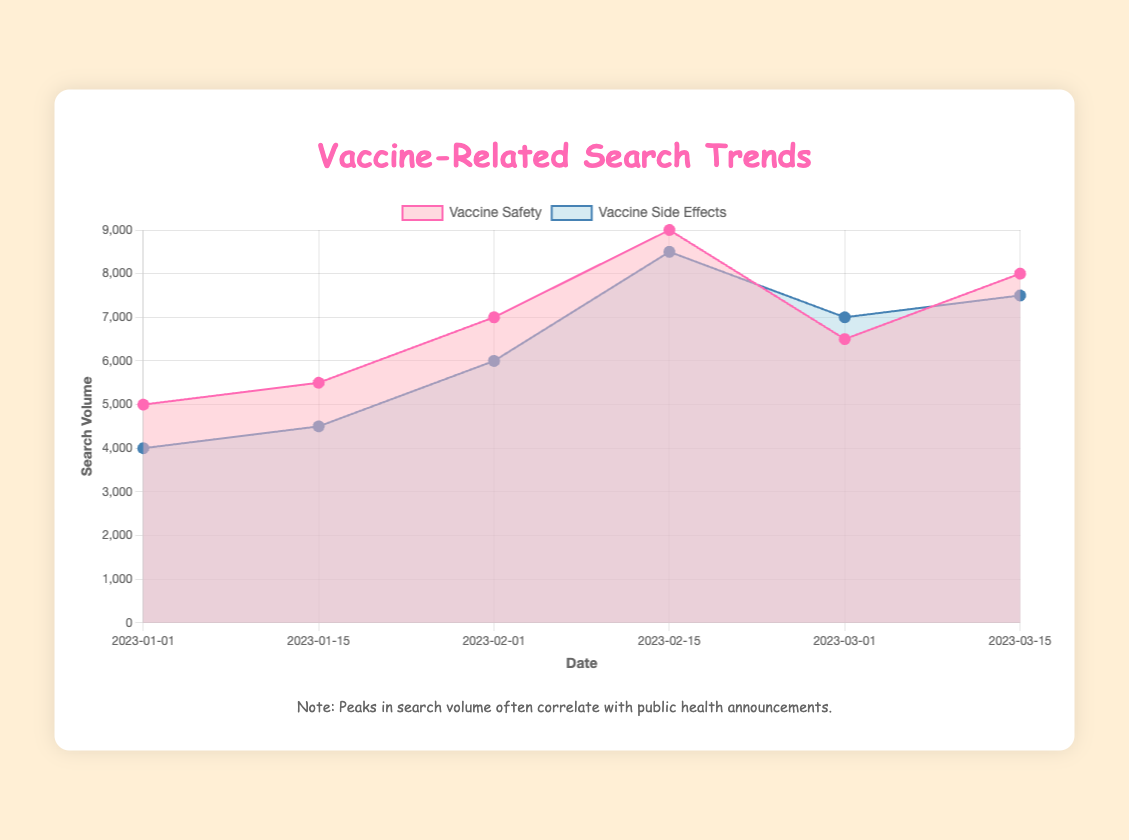What is the title of the chart? The chart's title is displayed prominently at the top of the chart's container. It provides a summary of what the chart is about.
Answer: Vaccine-Related Search Trends What are the two search terms being analyzed in the chart? The chart includes two datasets differentiated by color, and each dataset is labeled in the legend.
Answer: Vaccine Safety, Vaccine Side Effects Which search term experienced a higher search volume on February 15, 2023? By looking at the data points on February 15, 2023, it is clear which dataset has a higher search volume.
Answer: Vaccine Side Effects What visual indicators are used to represent the search volume for "vaccine safety" and "vaccine side effects"? Different colors and styles (pink for vaccine safety and blue for vaccine side effects) are used to differentiate the datasets.
Answer: Pink and Blue Areas Does the search volume for both terms increase or decrease between January 15 and February 1, 2023? By comparing the search volumes for both terms on these dates, we can observe the trends.
Answer: Increase for both What was the search volume for "vaccine safety" on March 1, 2023? Looking at the data point for "vaccine safety" on March 1, 2023, gives the answer.
Answer: 6500 How does the search volume for "vaccine side effects" on February 1, 2023, compare to the search volume for "vaccine safety" on that same date? By comparing the data points of both terms on February 1, 2023, we can see which one is higher or if they are the same.
Answer: Higher Which public health announcements correlate with peaks in search volume? By observing the labels for public health announcements and matching them with peaks in the search volume, we can identify the correlating announcements.
Answer: CDC releases new vaccine safety study, WHO addresses vaccine misinformation What is the relationship between public health announcements and search volume trends? Comparing the dates of public health announcements with spikes in the search volumes can reveal a pattern or relationship.
Answer: Peaks often follow announcements Identify the term that shows a consistent increase in search volume over the first three months of 2023. By analyzing the overall trend for each term, we identify which one shows a steady increase.
Answer: Vaccine Side Effects 